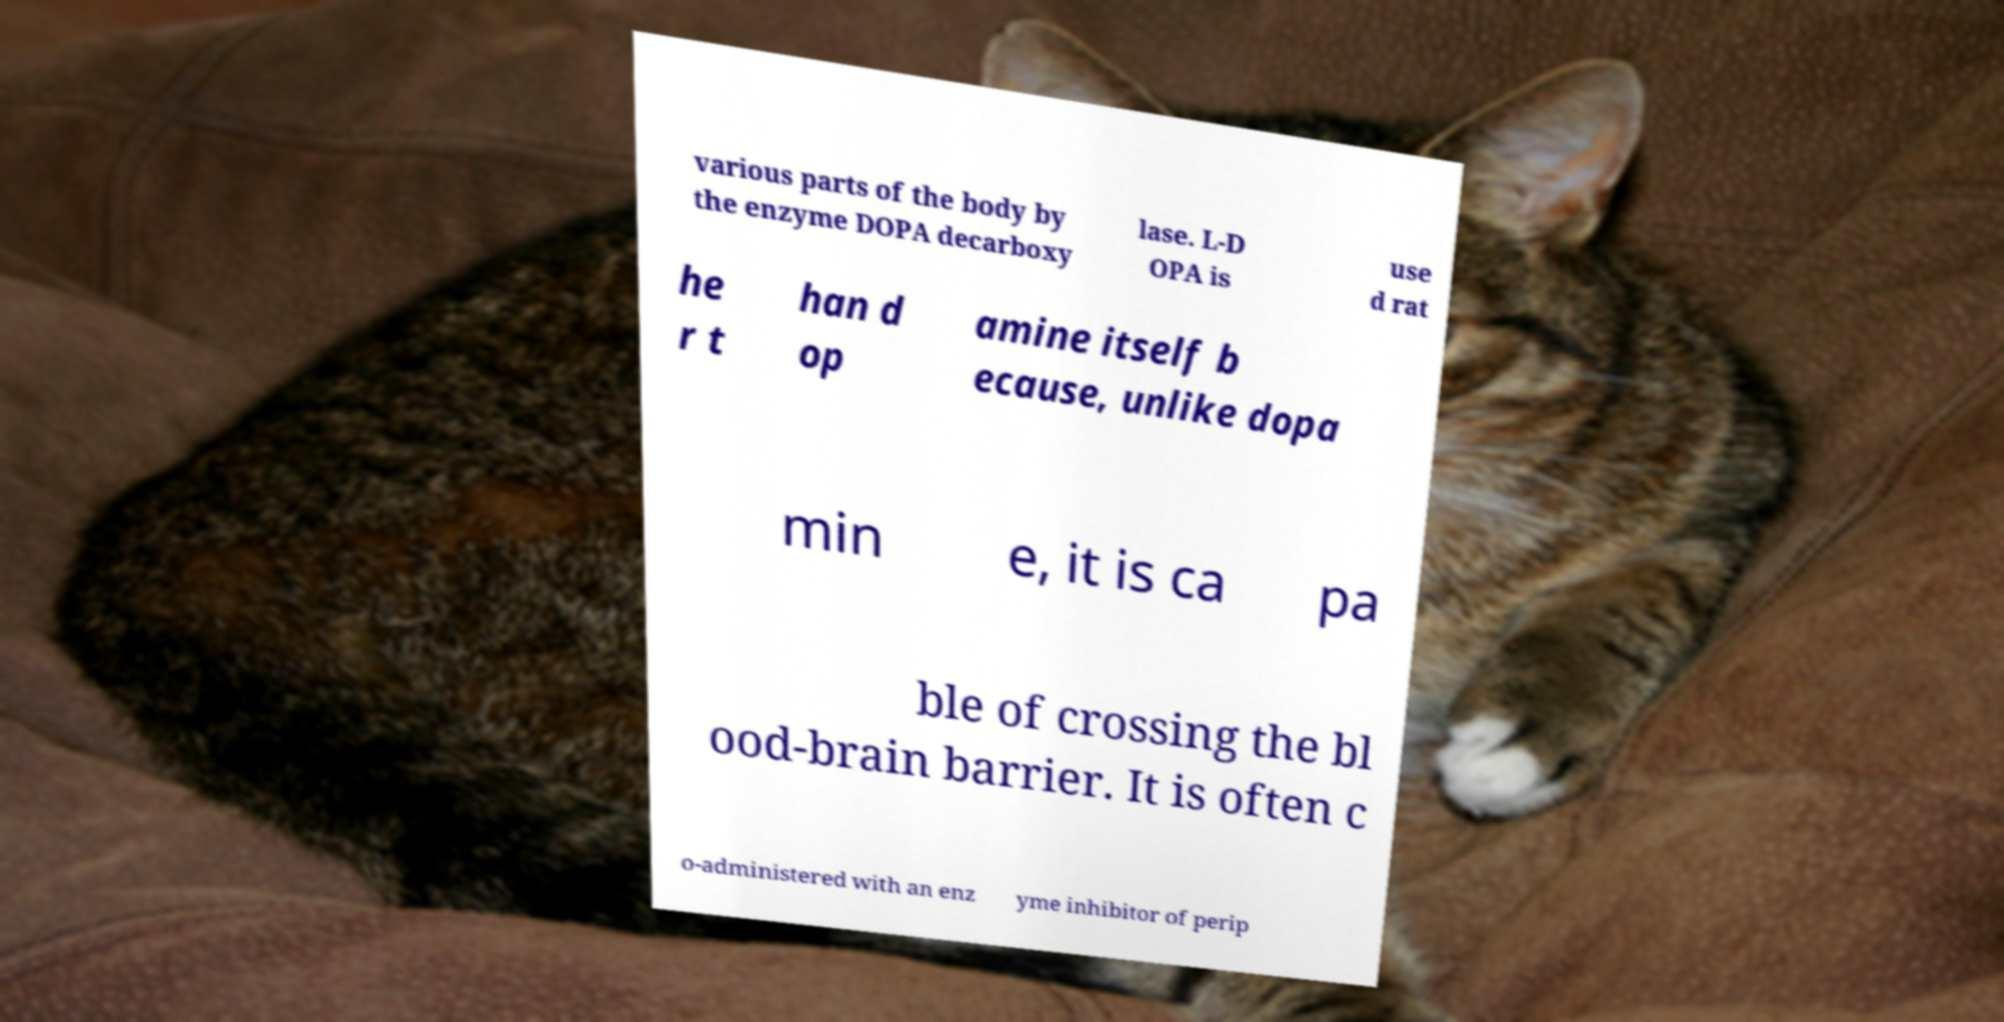Can you accurately transcribe the text from the provided image for me? various parts of the body by the enzyme DOPA decarboxy lase. L-D OPA is use d rat he r t han d op amine itself b ecause, unlike dopa min e, it is ca pa ble of crossing the bl ood-brain barrier. It is often c o-administered with an enz yme inhibitor of perip 